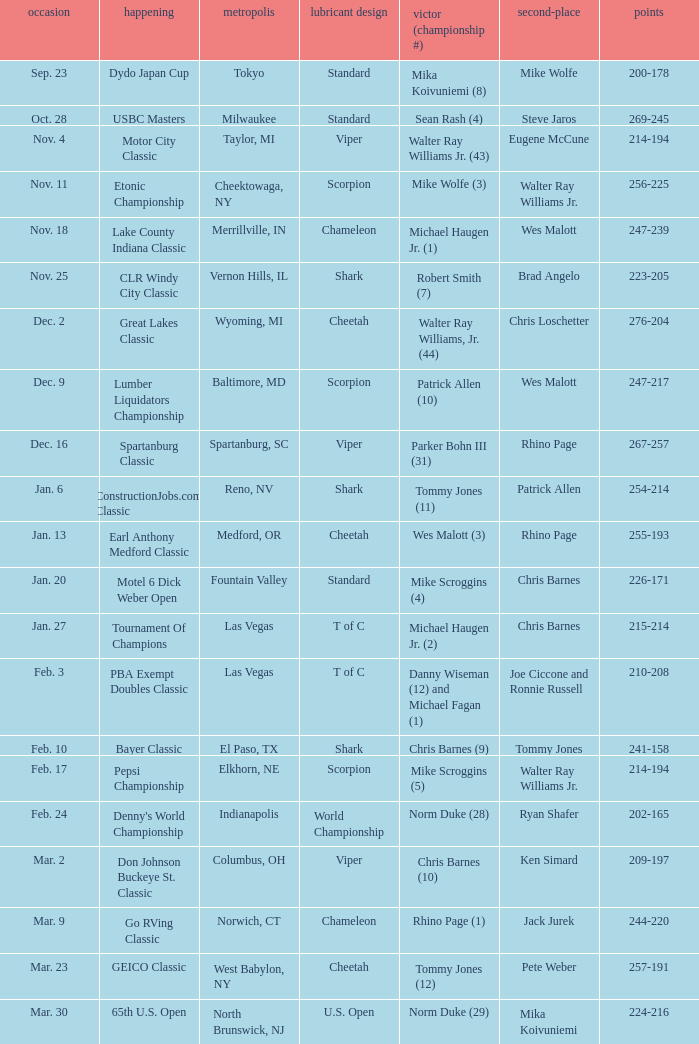Name the Event which has a Score of 209-197? Don Johnson Buckeye St. Classic. 